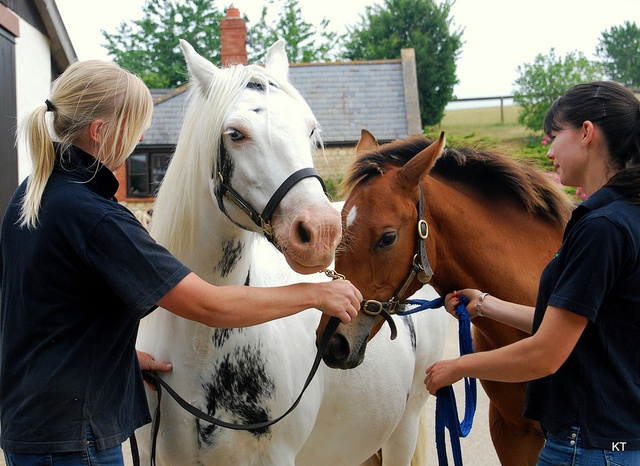Describe the objects in this image and their specific colors. I can see horse in black, lightgray, darkgray, and gray tones, people in black, gray, and tan tones, people in black, brown, and maroon tones, and horse in black, maroon, and brown tones in this image. 